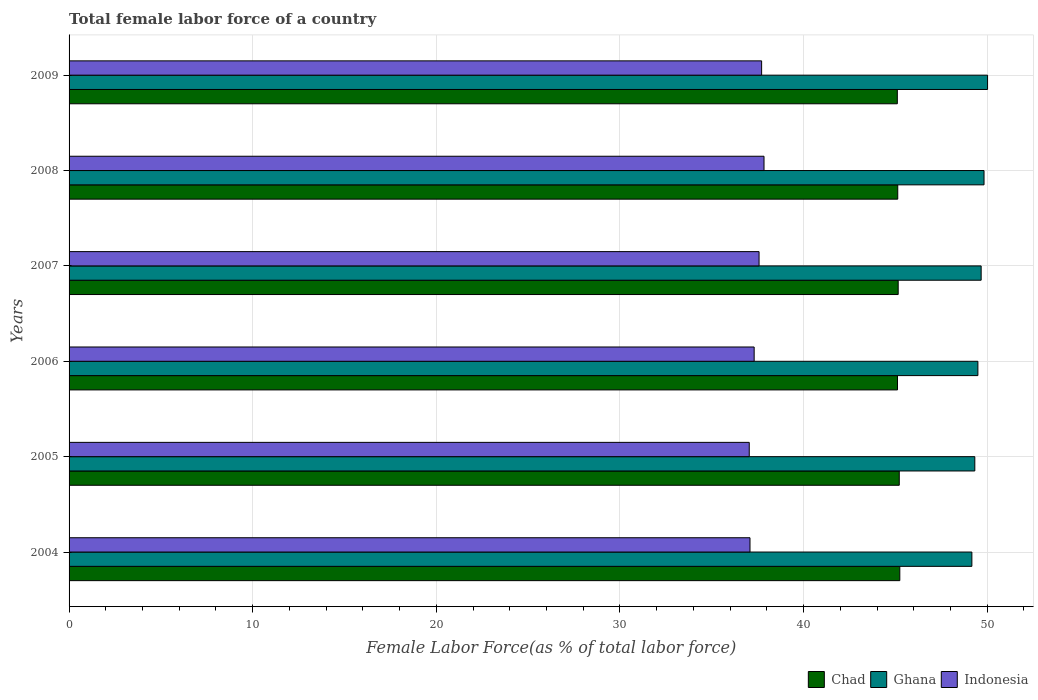How many groups of bars are there?
Provide a succinct answer. 6. Are the number of bars per tick equal to the number of legend labels?
Give a very brief answer. Yes. Are the number of bars on each tick of the Y-axis equal?
Offer a terse response. Yes. How many bars are there on the 5th tick from the top?
Your response must be concise. 3. What is the label of the 2nd group of bars from the top?
Provide a short and direct response. 2008. What is the percentage of female labor force in Ghana in 2009?
Give a very brief answer. 50.02. Across all years, what is the maximum percentage of female labor force in Ghana?
Your answer should be compact. 50.02. Across all years, what is the minimum percentage of female labor force in Indonesia?
Offer a very short reply. 37.04. In which year was the percentage of female labor force in Ghana maximum?
Provide a short and direct response. 2009. In which year was the percentage of female labor force in Chad minimum?
Provide a short and direct response. 2009. What is the total percentage of female labor force in Indonesia in the graph?
Your answer should be very brief. 224.58. What is the difference between the percentage of female labor force in Indonesia in 2007 and that in 2009?
Provide a succinct answer. -0.14. What is the difference between the percentage of female labor force in Indonesia in 2005 and the percentage of female labor force in Chad in 2008?
Your answer should be very brief. -8.09. What is the average percentage of female labor force in Ghana per year?
Give a very brief answer. 49.59. In the year 2007, what is the difference between the percentage of female labor force in Chad and percentage of female labor force in Indonesia?
Your answer should be very brief. 7.58. In how many years, is the percentage of female labor force in Ghana greater than 24 %?
Your response must be concise. 6. What is the ratio of the percentage of female labor force in Ghana in 2006 to that in 2007?
Provide a succinct answer. 1. Is the percentage of female labor force in Indonesia in 2005 less than that in 2009?
Keep it short and to the point. Yes. Is the difference between the percentage of female labor force in Chad in 2006 and 2009 greater than the difference between the percentage of female labor force in Indonesia in 2006 and 2009?
Your answer should be very brief. Yes. What is the difference between the highest and the second highest percentage of female labor force in Chad?
Provide a succinct answer. 0.03. What is the difference between the highest and the lowest percentage of female labor force in Chad?
Ensure brevity in your answer.  0.14. In how many years, is the percentage of female labor force in Indonesia greater than the average percentage of female labor force in Indonesia taken over all years?
Provide a succinct answer. 3. Is the sum of the percentage of female labor force in Indonesia in 2006 and 2008 greater than the maximum percentage of female labor force in Ghana across all years?
Make the answer very short. Yes. What does the 1st bar from the top in 2006 represents?
Offer a very short reply. Indonesia. How many years are there in the graph?
Give a very brief answer. 6. What is the difference between two consecutive major ticks on the X-axis?
Make the answer very short. 10. Are the values on the major ticks of X-axis written in scientific E-notation?
Make the answer very short. No. Where does the legend appear in the graph?
Your answer should be very brief. Bottom right. How are the legend labels stacked?
Provide a succinct answer. Horizontal. What is the title of the graph?
Your answer should be very brief. Total female labor force of a country. Does "Nigeria" appear as one of the legend labels in the graph?
Make the answer very short. No. What is the label or title of the X-axis?
Offer a terse response. Female Labor Force(as % of total labor force). What is the Female Labor Force(as % of total labor force) of Chad in 2004?
Provide a short and direct response. 45.24. What is the Female Labor Force(as % of total labor force) in Ghana in 2004?
Keep it short and to the point. 49.17. What is the Female Labor Force(as % of total labor force) in Indonesia in 2004?
Ensure brevity in your answer.  37.08. What is the Female Labor Force(as % of total labor force) in Chad in 2005?
Provide a succinct answer. 45.21. What is the Female Labor Force(as % of total labor force) in Ghana in 2005?
Your answer should be compact. 49.33. What is the Female Labor Force(as % of total labor force) of Indonesia in 2005?
Your answer should be compact. 37.04. What is the Female Labor Force(as % of total labor force) of Chad in 2006?
Make the answer very short. 45.12. What is the Female Labor Force(as % of total labor force) of Ghana in 2006?
Provide a succinct answer. 49.49. What is the Female Labor Force(as % of total labor force) of Indonesia in 2006?
Keep it short and to the point. 37.31. What is the Female Labor Force(as % of total labor force) in Chad in 2007?
Give a very brief answer. 45.15. What is the Female Labor Force(as % of total labor force) of Ghana in 2007?
Keep it short and to the point. 49.67. What is the Female Labor Force(as % of total labor force) in Indonesia in 2007?
Your answer should be very brief. 37.58. What is the Female Labor Force(as % of total labor force) in Chad in 2008?
Provide a short and direct response. 45.13. What is the Female Labor Force(as % of total labor force) of Ghana in 2008?
Keep it short and to the point. 49.83. What is the Female Labor Force(as % of total labor force) in Indonesia in 2008?
Your response must be concise. 37.85. What is the Female Labor Force(as % of total labor force) in Chad in 2009?
Ensure brevity in your answer.  45.11. What is the Female Labor Force(as % of total labor force) in Ghana in 2009?
Your answer should be compact. 50.02. What is the Female Labor Force(as % of total labor force) in Indonesia in 2009?
Offer a very short reply. 37.72. Across all years, what is the maximum Female Labor Force(as % of total labor force) of Chad?
Provide a succinct answer. 45.24. Across all years, what is the maximum Female Labor Force(as % of total labor force) of Ghana?
Provide a short and direct response. 50.02. Across all years, what is the maximum Female Labor Force(as % of total labor force) in Indonesia?
Your answer should be very brief. 37.85. Across all years, what is the minimum Female Labor Force(as % of total labor force) of Chad?
Your response must be concise. 45.11. Across all years, what is the minimum Female Labor Force(as % of total labor force) of Ghana?
Keep it short and to the point. 49.17. Across all years, what is the minimum Female Labor Force(as % of total labor force) in Indonesia?
Your answer should be compact. 37.04. What is the total Female Labor Force(as % of total labor force) in Chad in the graph?
Your answer should be compact. 270.96. What is the total Female Labor Force(as % of total labor force) in Ghana in the graph?
Your answer should be compact. 297.51. What is the total Female Labor Force(as % of total labor force) in Indonesia in the graph?
Your response must be concise. 224.58. What is the difference between the Female Labor Force(as % of total labor force) in Chad in 2004 and that in 2005?
Offer a terse response. 0.03. What is the difference between the Female Labor Force(as % of total labor force) in Ghana in 2004 and that in 2005?
Give a very brief answer. -0.16. What is the difference between the Female Labor Force(as % of total labor force) in Indonesia in 2004 and that in 2005?
Offer a very short reply. 0.04. What is the difference between the Female Labor Force(as % of total labor force) of Chad in 2004 and that in 2006?
Ensure brevity in your answer.  0.13. What is the difference between the Female Labor Force(as % of total labor force) of Ghana in 2004 and that in 2006?
Provide a short and direct response. -0.33. What is the difference between the Female Labor Force(as % of total labor force) in Indonesia in 2004 and that in 2006?
Keep it short and to the point. -0.23. What is the difference between the Female Labor Force(as % of total labor force) of Chad in 2004 and that in 2007?
Provide a succinct answer. 0.09. What is the difference between the Female Labor Force(as % of total labor force) of Ghana in 2004 and that in 2007?
Offer a terse response. -0.51. What is the difference between the Female Labor Force(as % of total labor force) in Indonesia in 2004 and that in 2007?
Offer a very short reply. -0.49. What is the difference between the Female Labor Force(as % of total labor force) in Chad in 2004 and that in 2008?
Provide a short and direct response. 0.11. What is the difference between the Female Labor Force(as % of total labor force) in Ghana in 2004 and that in 2008?
Make the answer very short. -0.66. What is the difference between the Female Labor Force(as % of total labor force) of Indonesia in 2004 and that in 2008?
Give a very brief answer. -0.76. What is the difference between the Female Labor Force(as % of total labor force) of Chad in 2004 and that in 2009?
Provide a short and direct response. 0.14. What is the difference between the Female Labor Force(as % of total labor force) of Ghana in 2004 and that in 2009?
Ensure brevity in your answer.  -0.85. What is the difference between the Female Labor Force(as % of total labor force) in Indonesia in 2004 and that in 2009?
Your response must be concise. -0.63. What is the difference between the Female Labor Force(as % of total labor force) in Chad in 2005 and that in 2006?
Offer a very short reply. 0.1. What is the difference between the Female Labor Force(as % of total labor force) in Ghana in 2005 and that in 2006?
Provide a short and direct response. -0.17. What is the difference between the Female Labor Force(as % of total labor force) in Indonesia in 2005 and that in 2006?
Keep it short and to the point. -0.27. What is the difference between the Female Labor Force(as % of total labor force) in Chad in 2005 and that in 2007?
Keep it short and to the point. 0.06. What is the difference between the Female Labor Force(as % of total labor force) of Ghana in 2005 and that in 2007?
Provide a short and direct response. -0.35. What is the difference between the Female Labor Force(as % of total labor force) of Indonesia in 2005 and that in 2007?
Make the answer very short. -0.53. What is the difference between the Female Labor Force(as % of total labor force) of Chad in 2005 and that in 2008?
Ensure brevity in your answer.  0.08. What is the difference between the Female Labor Force(as % of total labor force) of Ghana in 2005 and that in 2008?
Give a very brief answer. -0.5. What is the difference between the Female Labor Force(as % of total labor force) in Indonesia in 2005 and that in 2008?
Your answer should be compact. -0.8. What is the difference between the Female Labor Force(as % of total labor force) in Chad in 2005 and that in 2009?
Your answer should be very brief. 0.11. What is the difference between the Female Labor Force(as % of total labor force) in Ghana in 2005 and that in 2009?
Provide a succinct answer. -0.69. What is the difference between the Female Labor Force(as % of total labor force) in Indonesia in 2005 and that in 2009?
Offer a very short reply. -0.67. What is the difference between the Female Labor Force(as % of total labor force) of Chad in 2006 and that in 2007?
Give a very brief answer. -0.04. What is the difference between the Female Labor Force(as % of total labor force) in Ghana in 2006 and that in 2007?
Offer a terse response. -0.18. What is the difference between the Female Labor Force(as % of total labor force) of Indonesia in 2006 and that in 2007?
Your answer should be compact. -0.27. What is the difference between the Female Labor Force(as % of total labor force) of Chad in 2006 and that in 2008?
Make the answer very short. -0.01. What is the difference between the Female Labor Force(as % of total labor force) in Ghana in 2006 and that in 2008?
Keep it short and to the point. -0.33. What is the difference between the Female Labor Force(as % of total labor force) in Indonesia in 2006 and that in 2008?
Give a very brief answer. -0.54. What is the difference between the Female Labor Force(as % of total labor force) of Chad in 2006 and that in 2009?
Offer a very short reply. 0.01. What is the difference between the Female Labor Force(as % of total labor force) in Ghana in 2006 and that in 2009?
Your answer should be compact. -0.53. What is the difference between the Female Labor Force(as % of total labor force) of Indonesia in 2006 and that in 2009?
Offer a terse response. -0.41. What is the difference between the Female Labor Force(as % of total labor force) of Chad in 2007 and that in 2008?
Give a very brief answer. 0.02. What is the difference between the Female Labor Force(as % of total labor force) of Ghana in 2007 and that in 2008?
Ensure brevity in your answer.  -0.16. What is the difference between the Female Labor Force(as % of total labor force) of Indonesia in 2007 and that in 2008?
Ensure brevity in your answer.  -0.27. What is the difference between the Female Labor Force(as % of total labor force) of Chad in 2007 and that in 2009?
Your answer should be compact. 0.05. What is the difference between the Female Labor Force(as % of total labor force) of Ghana in 2007 and that in 2009?
Provide a succinct answer. -0.35. What is the difference between the Female Labor Force(as % of total labor force) of Indonesia in 2007 and that in 2009?
Give a very brief answer. -0.14. What is the difference between the Female Labor Force(as % of total labor force) in Chad in 2008 and that in 2009?
Your answer should be very brief. 0.02. What is the difference between the Female Labor Force(as % of total labor force) in Ghana in 2008 and that in 2009?
Your answer should be compact. -0.19. What is the difference between the Female Labor Force(as % of total labor force) in Indonesia in 2008 and that in 2009?
Keep it short and to the point. 0.13. What is the difference between the Female Labor Force(as % of total labor force) of Chad in 2004 and the Female Labor Force(as % of total labor force) of Ghana in 2005?
Make the answer very short. -4.08. What is the difference between the Female Labor Force(as % of total labor force) in Chad in 2004 and the Female Labor Force(as % of total labor force) in Indonesia in 2005?
Provide a short and direct response. 8.2. What is the difference between the Female Labor Force(as % of total labor force) in Ghana in 2004 and the Female Labor Force(as % of total labor force) in Indonesia in 2005?
Offer a very short reply. 12.12. What is the difference between the Female Labor Force(as % of total labor force) in Chad in 2004 and the Female Labor Force(as % of total labor force) in Ghana in 2006?
Provide a succinct answer. -4.25. What is the difference between the Female Labor Force(as % of total labor force) in Chad in 2004 and the Female Labor Force(as % of total labor force) in Indonesia in 2006?
Provide a succinct answer. 7.93. What is the difference between the Female Labor Force(as % of total labor force) in Ghana in 2004 and the Female Labor Force(as % of total labor force) in Indonesia in 2006?
Offer a very short reply. 11.86. What is the difference between the Female Labor Force(as % of total labor force) of Chad in 2004 and the Female Labor Force(as % of total labor force) of Ghana in 2007?
Provide a succinct answer. -4.43. What is the difference between the Female Labor Force(as % of total labor force) of Chad in 2004 and the Female Labor Force(as % of total labor force) of Indonesia in 2007?
Offer a very short reply. 7.67. What is the difference between the Female Labor Force(as % of total labor force) in Ghana in 2004 and the Female Labor Force(as % of total labor force) in Indonesia in 2007?
Your response must be concise. 11.59. What is the difference between the Female Labor Force(as % of total labor force) of Chad in 2004 and the Female Labor Force(as % of total labor force) of Ghana in 2008?
Your response must be concise. -4.59. What is the difference between the Female Labor Force(as % of total labor force) in Chad in 2004 and the Female Labor Force(as % of total labor force) in Indonesia in 2008?
Make the answer very short. 7.4. What is the difference between the Female Labor Force(as % of total labor force) in Ghana in 2004 and the Female Labor Force(as % of total labor force) in Indonesia in 2008?
Ensure brevity in your answer.  11.32. What is the difference between the Female Labor Force(as % of total labor force) of Chad in 2004 and the Female Labor Force(as % of total labor force) of Ghana in 2009?
Provide a short and direct response. -4.78. What is the difference between the Female Labor Force(as % of total labor force) in Chad in 2004 and the Female Labor Force(as % of total labor force) in Indonesia in 2009?
Offer a terse response. 7.53. What is the difference between the Female Labor Force(as % of total labor force) of Ghana in 2004 and the Female Labor Force(as % of total labor force) of Indonesia in 2009?
Offer a very short reply. 11.45. What is the difference between the Female Labor Force(as % of total labor force) in Chad in 2005 and the Female Labor Force(as % of total labor force) in Ghana in 2006?
Keep it short and to the point. -4.28. What is the difference between the Female Labor Force(as % of total labor force) in Chad in 2005 and the Female Labor Force(as % of total labor force) in Indonesia in 2006?
Keep it short and to the point. 7.9. What is the difference between the Female Labor Force(as % of total labor force) of Ghana in 2005 and the Female Labor Force(as % of total labor force) of Indonesia in 2006?
Keep it short and to the point. 12.02. What is the difference between the Female Labor Force(as % of total labor force) of Chad in 2005 and the Female Labor Force(as % of total labor force) of Ghana in 2007?
Make the answer very short. -4.46. What is the difference between the Female Labor Force(as % of total labor force) in Chad in 2005 and the Female Labor Force(as % of total labor force) in Indonesia in 2007?
Keep it short and to the point. 7.64. What is the difference between the Female Labor Force(as % of total labor force) in Ghana in 2005 and the Female Labor Force(as % of total labor force) in Indonesia in 2007?
Make the answer very short. 11.75. What is the difference between the Female Labor Force(as % of total labor force) of Chad in 2005 and the Female Labor Force(as % of total labor force) of Ghana in 2008?
Your answer should be very brief. -4.62. What is the difference between the Female Labor Force(as % of total labor force) of Chad in 2005 and the Female Labor Force(as % of total labor force) of Indonesia in 2008?
Make the answer very short. 7.37. What is the difference between the Female Labor Force(as % of total labor force) in Ghana in 2005 and the Female Labor Force(as % of total labor force) in Indonesia in 2008?
Keep it short and to the point. 11.48. What is the difference between the Female Labor Force(as % of total labor force) in Chad in 2005 and the Female Labor Force(as % of total labor force) in Ghana in 2009?
Ensure brevity in your answer.  -4.81. What is the difference between the Female Labor Force(as % of total labor force) of Chad in 2005 and the Female Labor Force(as % of total labor force) of Indonesia in 2009?
Your answer should be compact. 7.5. What is the difference between the Female Labor Force(as % of total labor force) of Ghana in 2005 and the Female Labor Force(as % of total labor force) of Indonesia in 2009?
Offer a very short reply. 11.61. What is the difference between the Female Labor Force(as % of total labor force) in Chad in 2006 and the Female Labor Force(as % of total labor force) in Ghana in 2007?
Your answer should be very brief. -4.56. What is the difference between the Female Labor Force(as % of total labor force) of Chad in 2006 and the Female Labor Force(as % of total labor force) of Indonesia in 2007?
Provide a short and direct response. 7.54. What is the difference between the Female Labor Force(as % of total labor force) of Ghana in 2006 and the Female Labor Force(as % of total labor force) of Indonesia in 2007?
Give a very brief answer. 11.92. What is the difference between the Female Labor Force(as % of total labor force) in Chad in 2006 and the Female Labor Force(as % of total labor force) in Ghana in 2008?
Offer a very short reply. -4.71. What is the difference between the Female Labor Force(as % of total labor force) in Chad in 2006 and the Female Labor Force(as % of total labor force) in Indonesia in 2008?
Provide a short and direct response. 7.27. What is the difference between the Female Labor Force(as % of total labor force) of Ghana in 2006 and the Female Labor Force(as % of total labor force) of Indonesia in 2008?
Offer a terse response. 11.65. What is the difference between the Female Labor Force(as % of total labor force) in Chad in 2006 and the Female Labor Force(as % of total labor force) in Ghana in 2009?
Give a very brief answer. -4.91. What is the difference between the Female Labor Force(as % of total labor force) of Chad in 2006 and the Female Labor Force(as % of total labor force) of Indonesia in 2009?
Offer a very short reply. 7.4. What is the difference between the Female Labor Force(as % of total labor force) in Ghana in 2006 and the Female Labor Force(as % of total labor force) in Indonesia in 2009?
Ensure brevity in your answer.  11.78. What is the difference between the Female Labor Force(as % of total labor force) in Chad in 2007 and the Female Labor Force(as % of total labor force) in Ghana in 2008?
Offer a terse response. -4.67. What is the difference between the Female Labor Force(as % of total labor force) in Chad in 2007 and the Female Labor Force(as % of total labor force) in Indonesia in 2008?
Offer a very short reply. 7.31. What is the difference between the Female Labor Force(as % of total labor force) in Ghana in 2007 and the Female Labor Force(as % of total labor force) in Indonesia in 2008?
Your response must be concise. 11.83. What is the difference between the Female Labor Force(as % of total labor force) of Chad in 2007 and the Female Labor Force(as % of total labor force) of Ghana in 2009?
Provide a succinct answer. -4.87. What is the difference between the Female Labor Force(as % of total labor force) of Chad in 2007 and the Female Labor Force(as % of total labor force) of Indonesia in 2009?
Your answer should be compact. 7.44. What is the difference between the Female Labor Force(as % of total labor force) in Ghana in 2007 and the Female Labor Force(as % of total labor force) in Indonesia in 2009?
Give a very brief answer. 11.96. What is the difference between the Female Labor Force(as % of total labor force) in Chad in 2008 and the Female Labor Force(as % of total labor force) in Ghana in 2009?
Provide a succinct answer. -4.89. What is the difference between the Female Labor Force(as % of total labor force) of Chad in 2008 and the Female Labor Force(as % of total labor force) of Indonesia in 2009?
Make the answer very short. 7.41. What is the difference between the Female Labor Force(as % of total labor force) in Ghana in 2008 and the Female Labor Force(as % of total labor force) in Indonesia in 2009?
Keep it short and to the point. 12.11. What is the average Female Labor Force(as % of total labor force) of Chad per year?
Make the answer very short. 45.16. What is the average Female Labor Force(as % of total labor force) of Ghana per year?
Offer a terse response. 49.59. What is the average Female Labor Force(as % of total labor force) in Indonesia per year?
Your response must be concise. 37.43. In the year 2004, what is the difference between the Female Labor Force(as % of total labor force) of Chad and Female Labor Force(as % of total labor force) of Ghana?
Your answer should be compact. -3.92. In the year 2004, what is the difference between the Female Labor Force(as % of total labor force) of Chad and Female Labor Force(as % of total labor force) of Indonesia?
Make the answer very short. 8.16. In the year 2004, what is the difference between the Female Labor Force(as % of total labor force) in Ghana and Female Labor Force(as % of total labor force) in Indonesia?
Your response must be concise. 12.08. In the year 2005, what is the difference between the Female Labor Force(as % of total labor force) of Chad and Female Labor Force(as % of total labor force) of Ghana?
Provide a succinct answer. -4.11. In the year 2005, what is the difference between the Female Labor Force(as % of total labor force) in Chad and Female Labor Force(as % of total labor force) in Indonesia?
Offer a very short reply. 8.17. In the year 2005, what is the difference between the Female Labor Force(as % of total labor force) of Ghana and Female Labor Force(as % of total labor force) of Indonesia?
Ensure brevity in your answer.  12.28. In the year 2006, what is the difference between the Female Labor Force(as % of total labor force) of Chad and Female Labor Force(as % of total labor force) of Ghana?
Your answer should be very brief. -4.38. In the year 2006, what is the difference between the Female Labor Force(as % of total labor force) in Chad and Female Labor Force(as % of total labor force) in Indonesia?
Offer a very short reply. 7.81. In the year 2006, what is the difference between the Female Labor Force(as % of total labor force) in Ghana and Female Labor Force(as % of total labor force) in Indonesia?
Keep it short and to the point. 12.18. In the year 2007, what is the difference between the Female Labor Force(as % of total labor force) in Chad and Female Labor Force(as % of total labor force) in Ghana?
Keep it short and to the point. -4.52. In the year 2007, what is the difference between the Female Labor Force(as % of total labor force) in Chad and Female Labor Force(as % of total labor force) in Indonesia?
Provide a short and direct response. 7.58. In the year 2007, what is the difference between the Female Labor Force(as % of total labor force) in Ghana and Female Labor Force(as % of total labor force) in Indonesia?
Your answer should be very brief. 12.1. In the year 2008, what is the difference between the Female Labor Force(as % of total labor force) in Chad and Female Labor Force(as % of total labor force) in Ghana?
Your answer should be compact. -4.7. In the year 2008, what is the difference between the Female Labor Force(as % of total labor force) in Chad and Female Labor Force(as % of total labor force) in Indonesia?
Provide a succinct answer. 7.28. In the year 2008, what is the difference between the Female Labor Force(as % of total labor force) in Ghana and Female Labor Force(as % of total labor force) in Indonesia?
Give a very brief answer. 11.98. In the year 2009, what is the difference between the Female Labor Force(as % of total labor force) in Chad and Female Labor Force(as % of total labor force) in Ghana?
Offer a terse response. -4.91. In the year 2009, what is the difference between the Female Labor Force(as % of total labor force) of Chad and Female Labor Force(as % of total labor force) of Indonesia?
Offer a terse response. 7.39. In the year 2009, what is the difference between the Female Labor Force(as % of total labor force) of Ghana and Female Labor Force(as % of total labor force) of Indonesia?
Your answer should be very brief. 12.3. What is the ratio of the Female Labor Force(as % of total labor force) in Chad in 2004 to that in 2005?
Offer a very short reply. 1. What is the ratio of the Female Labor Force(as % of total labor force) of Ghana in 2004 to that in 2006?
Make the answer very short. 0.99. What is the ratio of the Female Labor Force(as % of total labor force) in Indonesia in 2004 to that in 2006?
Ensure brevity in your answer.  0.99. What is the ratio of the Female Labor Force(as % of total labor force) of Chad in 2004 to that in 2007?
Give a very brief answer. 1. What is the ratio of the Female Labor Force(as % of total labor force) in Ghana in 2004 to that in 2007?
Ensure brevity in your answer.  0.99. What is the ratio of the Female Labor Force(as % of total labor force) of Indonesia in 2004 to that in 2007?
Offer a very short reply. 0.99. What is the ratio of the Female Labor Force(as % of total labor force) in Chad in 2004 to that in 2008?
Offer a terse response. 1. What is the ratio of the Female Labor Force(as % of total labor force) in Ghana in 2004 to that in 2008?
Offer a terse response. 0.99. What is the ratio of the Female Labor Force(as % of total labor force) of Indonesia in 2004 to that in 2008?
Offer a terse response. 0.98. What is the ratio of the Female Labor Force(as % of total labor force) in Ghana in 2004 to that in 2009?
Offer a terse response. 0.98. What is the ratio of the Female Labor Force(as % of total labor force) in Indonesia in 2004 to that in 2009?
Provide a succinct answer. 0.98. What is the ratio of the Female Labor Force(as % of total labor force) of Chad in 2005 to that in 2006?
Your response must be concise. 1. What is the ratio of the Female Labor Force(as % of total labor force) in Ghana in 2005 to that in 2006?
Your answer should be compact. 1. What is the ratio of the Female Labor Force(as % of total labor force) of Indonesia in 2005 to that in 2006?
Your answer should be compact. 0.99. What is the ratio of the Female Labor Force(as % of total labor force) of Chad in 2005 to that in 2007?
Offer a terse response. 1. What is the ratio of the Female Labor Force(as % of total labor force) in Ghana in 2005 to that in 2007?
Keep it short and to the point. 0.99. What is the ratio of the Female Labor Force(as % of total labor force) of Indonesia in 2005 to that in 2007?
Your answer should be compact. 0.99. What is the ratio of the Female Labor Force(as % of total labor force) in Indonesia in 2005 to that in 2008?
Provide a succinct answer. 0.98. What is the ratio of the Female Labor Force(as % of total labor force) in Ghana in 2005 to that in 2009?
Your response must be concise. 0.99. What is the ratio of the Female Labor Force(as % of total labor force) in Indonesia in 2005 to that in 2009?
Give a very brief answer. 0.98. What is the ratio of the Female Labor Force(as % of total labor force) in Ghana in 2006 to that in 2007?
Your answer should be compact. 1. What is the ratio of the Female Labor Force(as % of total labor force) in Chad in 2006 to that in 2008?
Provide a short and direct response. 1. What is the ratio of the Female Labor Force(as % of total labor force) in Ghana in 2006 to that in 2008?
Give a very brief answer. 0.99. What is the ratio of the Female Labor Force(as % of total labor force) of Indonesia in 2006 to that in 2008?
Offer a very short reply. 0.99. What is the ratio of the Female Labor Force(as % of total labor force) of Chad in 2006 to that in 2009?
Offer a terse response. 1. What is the ratio of the Female Labor Force(as % of total labor force) of Indonesia in 2006 to that in 2009?
Provide a succinct answer. 0.99. What is the ratio of the Female Labor Force(as % of total labor force) in Chad in 2007 to that in 2008?
Make the answer very short. 1. What is the ratio of the Female Labor Force(as % of total labor force) of Ghana in 2007 to that in 2008?
Make the answer very short. 1. What is the ratio of the Female Labor Force(as % of total labor force) of Indonesia in 2007 to that in 2008?
Your answer should be compact. 0.99. What is the ratio of the Female Labor Force(as % of total labor force) of Chad in 2007 to that in 2009?
Provide a short and direct response. 1. What is the ratio of the Female Labor Force(as % of total labor force) in Ghana in 2007 to that in 2009?
Your answer should be very brief. 0.99. What is the ratio of the Female Labor Force(as % of total labor force) in Chad in 2008 to that in 2009?
Give a very brief answer. 1. What is the ratio of the Female Labor Force(as % of total labor force) of Indonesia in 2008 to that in 2009?
Offer a very short reply. 1. What is the difference between the highest and the second highest Female Labor Force(as % of total labor force) in Chad?
Give a very brief answer. 0.03. What is the difference between the highest and the second highest Female Labor Force(as % of total labor force) in Ghana?
Your response must be concise. 0.19. What is the difference between the highest and the second highest Female Labor Force(as % of total labor force) of Indonesia?
Your answer should be compact. 0.13. What is the difference between the highest and the lowest Female Labor Force(as % of total labor force) of Chad?
Your answer should be very brief. 0.14. What is the difference between the highest and the lowest Female Labor Force(as % of total labor force) in Ghana?
Offer a terse response. 0.85. What is the difference between the highest and the lowest Female Labor Force(as % of total labor force) in Indonesia?
Provide a short and direct response. 0.8. 